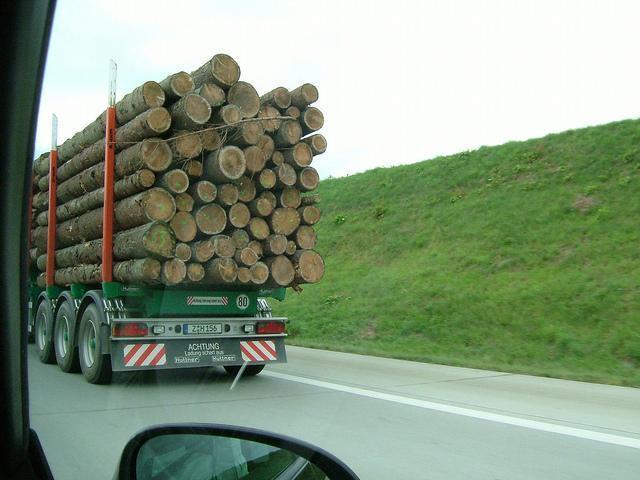How many train tracks do you see?
Give a very brief answer. 0. 